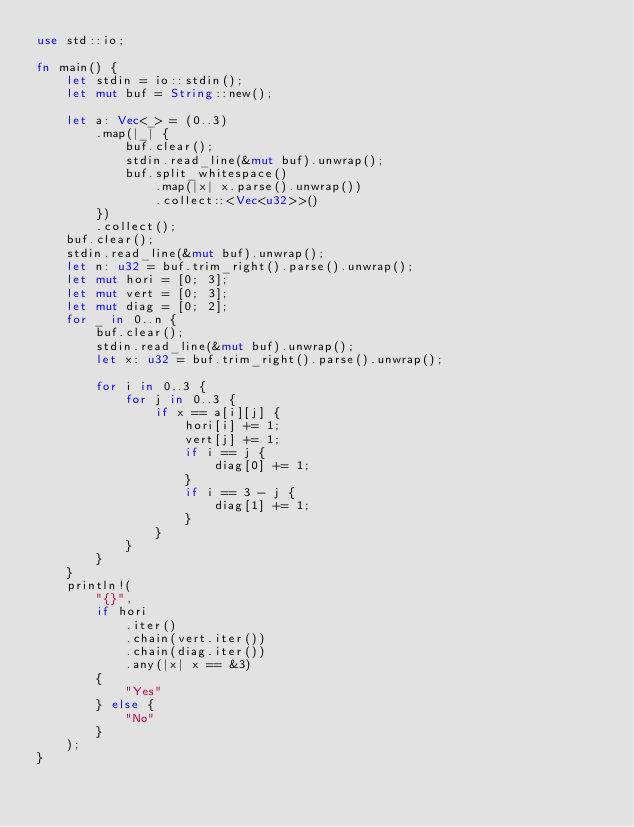<code> <loc_0><loc_0><loc_500><loc_500><_Rust_>use std::io;

fn main() {
    let stdin = io::stdin();
    let mut buf = String::new();

    let a: Vec<_> = (0..3)
        .map(|_| {
            buf.clear();
            stdin.read_line(&mut buf).unwrap();
            buf.split_whitespace()
                .map(|x| x.parse().unwrap())
                .collect::<Vec<u32>>()
        })
        .collect();
    buf.clear();
    stdin.read_line(&mut buf).unwrap();
    let n: u32 = buf.trim_right().parse().unwrap();
    let mut hori = [0; 3];
    let mut vert = [0; 3];
    let mut diag = [0; 2];
    for _ in 0..n {
        buf.clear();
        stdin.read_line(&mut buf).unwrap();
        let x: u32 = buf.trim_right().parse().unwrap();

        for i in 0..3 {
            for j in 0..3 {
                if x == a[i][j] {
                    hori[i] += 1;
                    vert[j] += 1;
                    if i == j {
                        diag[0] += 1;
                    }
                    if i == 3 - j {
                        diag[1] += 1;
                    }
                }
            }
        }
    }
    println!(
        "{}",
        if hori
            .iter()
            .chain(vert.iter())
            .chain(diag.iter())
            .any(|x| x == &3)
        {
            "Yes"
        } else {
            "No"
        }
    );
}
</code> 